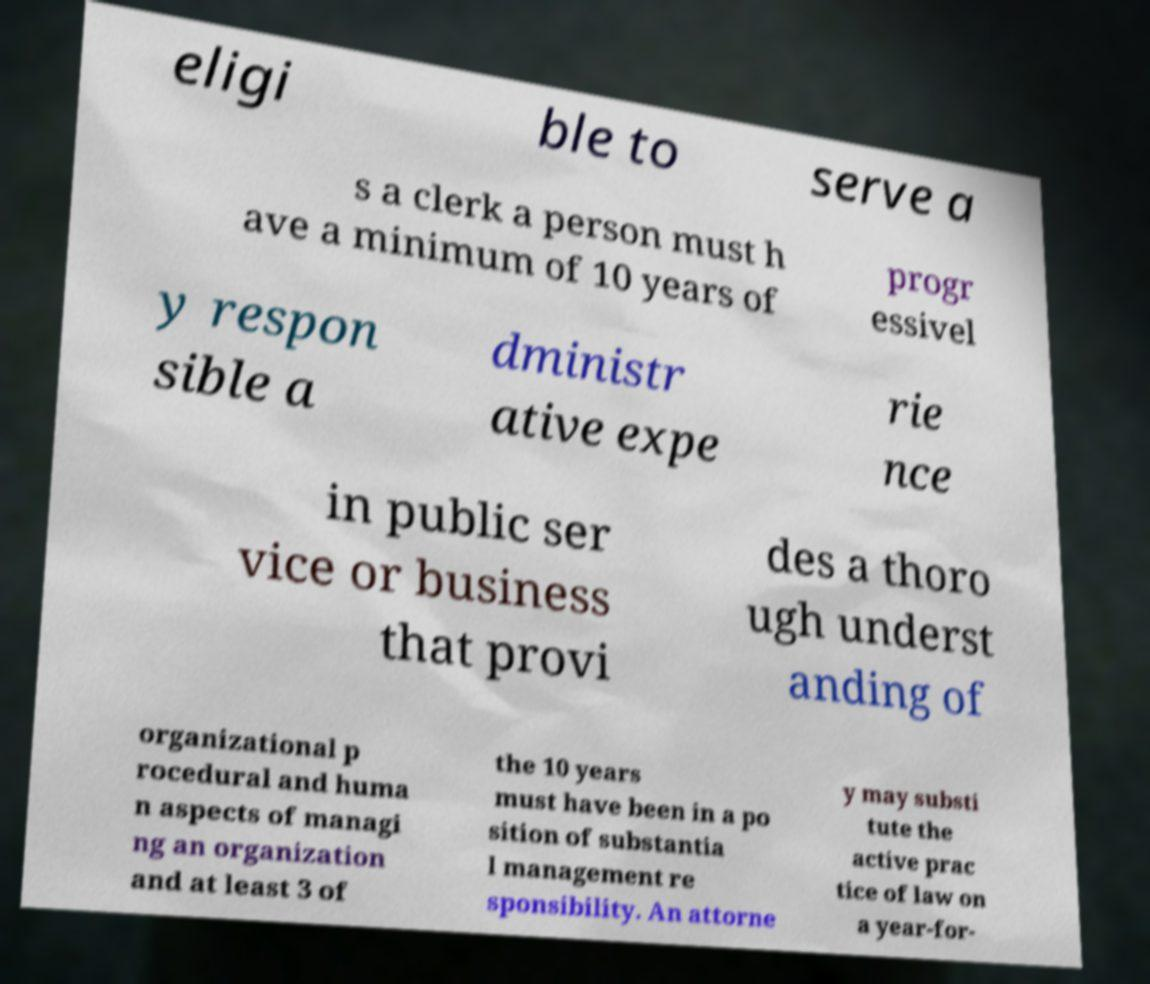For documentation purposes, I need the text within this image transcribed. Could you provide that? eligi ble to serve a s a clerk a person must h ave a minimum of 10 years of progr essivel y respon sible a dministr ative expe rie nce in public ser vice or business that provi des a thoro ugh underst anding of organizational p rocedural and huma n aspects of managi ng an organization and at least 3 of the 10 years must have been in a po sition of substantia l management re sponsibility. An attorne y may substi tute the active prac tice of law on a year-for- 